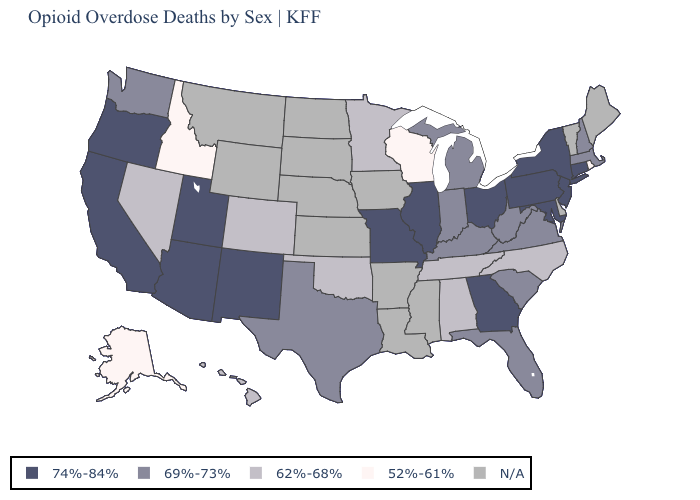What is the lowest value in the South?
Write a very short answer. 62%-68%. What is the value of North Dakota?
Write a very short answer. N/A. Among the states that border Vermont , which have the lowest value?
Answer briefly. Massachusetts, New Hampshire. What is the value of Georgia?
Give a very brief answer. 74%-84%. What is the lowest value in the USA?
Keep it brief. 52%-61%. What is the value of New Mexico?
Write a very short answer. 74%-84%. Among the states that border Vermont , does New York have the lowest value?
Answer briefly. No. Name the states that have a value in the range 52%-61%?
Be succinct. Alaska, Idaho, Rhode Island, Wisconsin. Name the states that have a value in the range 74%-84%?
Quick response, please. Arizona, California, Connecticut, Georgia, Illinois, Maryland, Missouri, New Jersey, New Mexico, New York, Ohio, Oregon, Pennsylvania, Utah. Is the legend a continuous bar?
Be succinct. No. Name the states that have a value in the range 52%-61%?
Write a very short answer. Alaska, Idaho, Rhode Island, Wisconsin. How many symbols are there in the legend?
Write a very short answer. 5. 